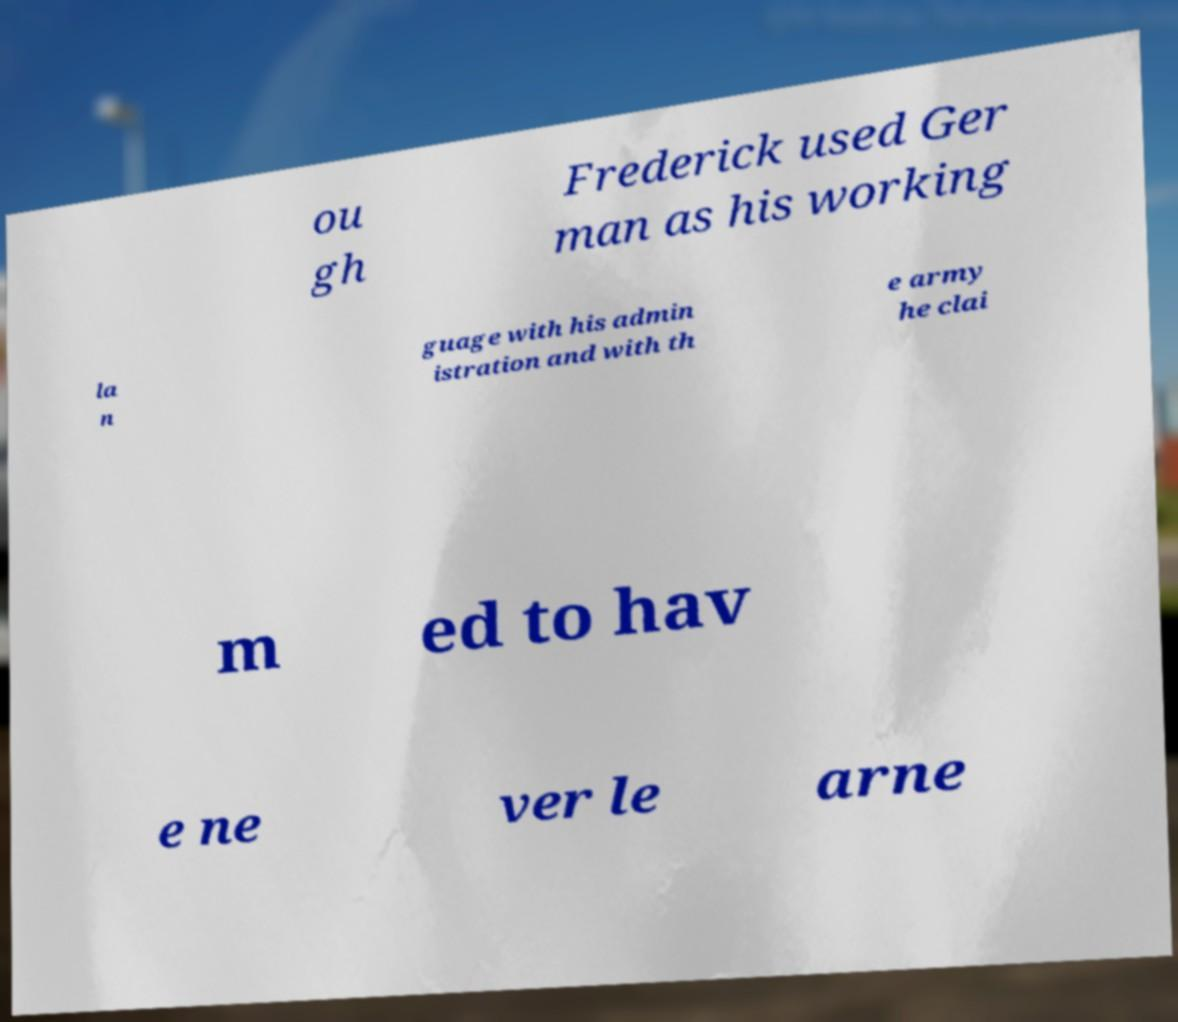Could you extract and type out the text from this image? ou gh Frederick used Ger man as his working la n guage with his admin istration and with th e army he clai m ed to hav e ne ver le arne 